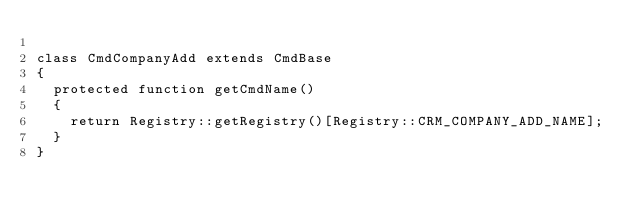<code> <loc_0><loc_0><loc_500><loc_500><_PHP_>
class CmdCompanyAdd extends CmdBase
{
	protected function getCmdName()
	{
		return Registry::getRegistry()[Registry::CRM_COMPANY_ADD_NAME];
	}
}</code> 